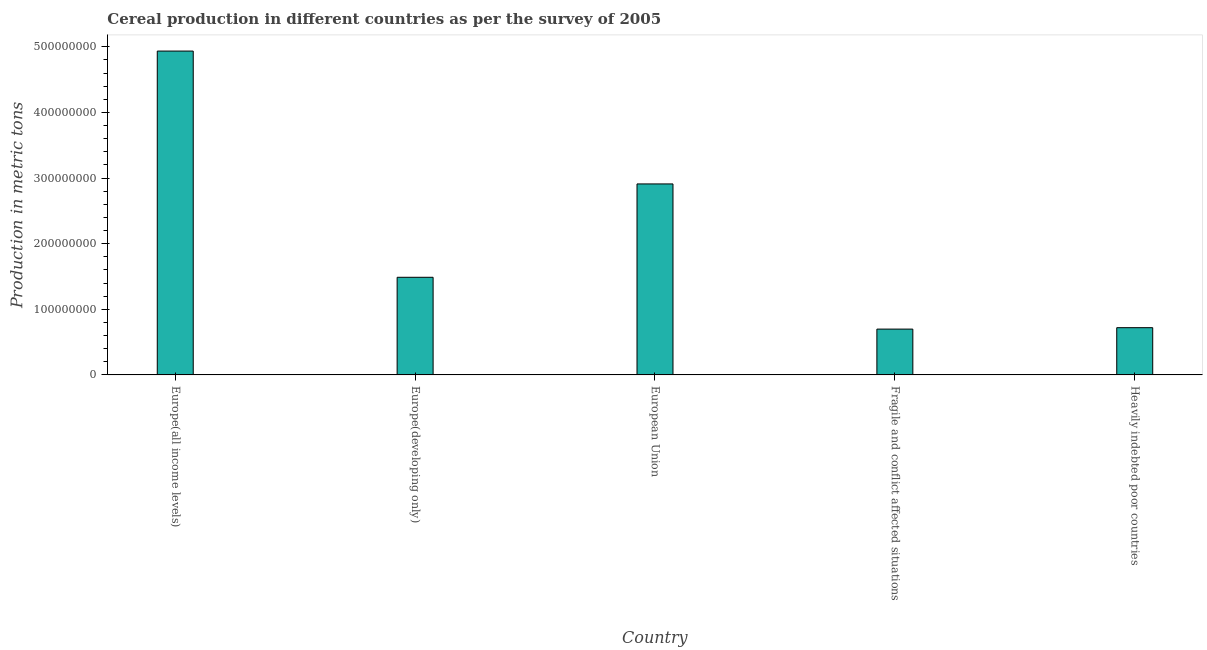What is the title of the graph?
Provide a succinct answer. Cereal production in different countries as per the survey of 2005. What is the label or title of the X-axis?
Offer a very short reply. Country. What is the label or title of the Y-axis?
Offer a very short reply. Production in metric tons. What is the cereal production in Europe(all income levels)?
Your answer should be very brief. 4.94e+08. Across all countries, what is the maximum cereal production?
Keep it short and to the point. 4.94e+08. Across all countries, what is the minimum cereal production?
Your answer should be very brief. 6.98e+07. In which country was the cereal production maximum?
Your answer should be compact. Europe(all income levels). In which country was the cereal production minimum?
Make the answer very short. Fragile and conflict affected situations. What is the sum of the cereal production?
Provide a short and direct response. 1.08e+09. What is the difference between the cereal production in European Union and Heavily indebted poor countries?
Your answer should be very brief. 2.19e+08. What is the average cereal production per country?
Provide a succinct answer. 2.15e+08. What is the median cereal production?
Ensure brevity in your answer.  1.49e+08. What is the ratio of the cereal production in Europe(all income levels) to that in European Union?
Provide a short and direct response. 1.7. Is the difference between the cereal production in Europe(all income levels) and Europe(developing only) greater than the difference between any two countries?
Ensure brevity in your answer.  No. What is the difference between the highest and the second highest cereal production?
Keep it short and to the point. 2.02e+08. Is the sum of the cereal production in Fragile and conflict affected situations and Heavily indebted poor countries greater than the maximum cereal production across all countries?
Offer a terse response. No. What is the difference between the highest and the lowest cereal production?
Your answer should be very brief. 4.24e+08. How many bars are there?
Your answer should be compact. 5. How many countries are there in the graph?
Keep it short and to the point. 5. What is the difference between two consecutive major ticks on the Y-axis?
Keep it short and to the point. 1.00e+08. Are the values on the major ticks of Y-axis written in scientific E-notation?
Your response must be concise. No. What is the Production in metric tons in Europe(all income levels)?
Your answer should be very brief. 4.94e+08. What is the Production in metric tons in Europe(developing only)?
Keep it short and to the point. 1.49e+08. What is the Production in metric tons of European Union?
Ensure brevity in your answer.  2.91e+08. What is the Production in metric tons in Fragile and conflict affected situations?
Ensure brevity in your answer.  6.98e+07. What is the Production in metric tons in Heavily indebted poor countries?
Your answer should be very brief. 7.20e+07. What is the difference between the Production in metric tons in Europe(all income levels) and Europe(developing only)?
Give a very brief answer. 3.45e+08. What is the difference between the Production in metric tons in Europe(all income levels) and European Union?
Make the answer very short. 2.02e+08. What is the difference between the Production in metric tons in Europe(all income levels) and Fragile and conflict affected situations?
Ensure brevity in your answer.  4.24e+08. What is the difference between the Production in metric tons in Europe(all income levels) and Heavily indebted poor countries?
Your answer should be very brief. 4.22e+08. What is the difference between the Production in metric tons in Europe(developing only) and European Union?
Keep it short and to the point. -1.42e+08. What is the difference between the Production in metric tons in Europe(developing only) and Fragile and conflict affected situations?
Provide a short and direct response. 7.90e+07. What is the difference between the Production in metric tons in Europe(developing only) and Heavily indebted poor countries?
Make the answer very short. 7.68e+07. What is the difference between the Production in metric tons in European Union and Fragile and conflict affected situations?
Give a very brief answer. 2.21e+08. What is the difference between the Production in metric tons in European Union and Heavily indebted poor countries?
Offer a very short reply. 2.19e+08. What is the difference between the Production in metric tons in Fragile and conflict affected situations and Heavily indebted poor countries?
Make the answer very short. -2.16e+06. What is the ratio of the Production in metric tons in Europe(all income levels) to that in Europe(developing only)?
Provide a short and direct response. 3.32. What is the ratio of the Production in metric tons in Europe(all income levels) to that in European Union?
Your answer should be compact. 1.7. What is the ratio of the Production in metric tons in Europe(all income levels) to that in Fragile and conflict affected situations?
Keep it short and to the point. 7.07. What is the ratio of the Production in metric tons in Europe(all income levels) to that in Heavily indebted poor countries?
Provide a succinct answer. 6.86. What is the ratio of the Production in metric tons in Europe(developing only) to that in European Union?
Ensure brevity in your answer.  0.51. What is the ratio of the Production in metric tons in Europe(developing only) to that in Fragile and conflict affected situations?
Ensure brevity in your answer.  2.13. What is the ratio of the Production in metric tons in Europe(developing only) to that in Heavily indebted poor countries?
Provide a short and direct response. 2.07. What is the ratio of the Production in metric tons in European Union to that in Fragile and conflict affected situations?
Offer a very short reply. 4.17. What is the ratio of the Production in metric tons in European Union to that in Heavily indebted poor countries?
Provide a succinct answer. 4.04. 